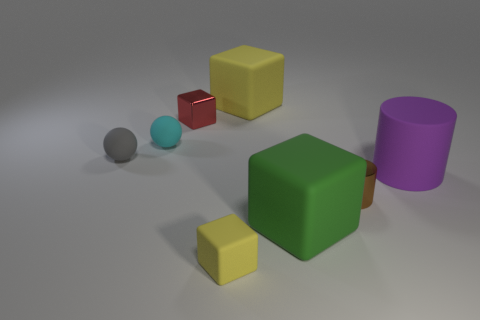There is a yellow thing behind the purple rubber cylinder; is its shape the same as the tiny rubber thing that is in front of the purple object?
Your answer should be compact. Yes. Are any large green blocks visible?
Make the answer very short. Yes. The other small thing that is the same shape as the small red metal thing is what color?
Keep it short and to the point. Yellow. What color is the other metal thing that is the same size as the brown shiny object?
Ensure brevity in your answer.  Red. Is the big purple cylinder made of the same material as the small red cube?
Offer a very short reply. No. How many big things have the same color as the small matte cube?
Ensure brevity in your answer.  1. There is a small object right of the green object; what is it made of?
Provide a succinct answer. Metal. How many large things are metal blocks or cyan metallic cubes?
Ensure brevity in your answer.  0. Is there a small cyan cube that has the same material as the purple cylinder?
Provide a succinct answer. No. Does the matte object to the right of the metallic cylinder have the same size as the small gray sphere?
Make the answer very short. No. 